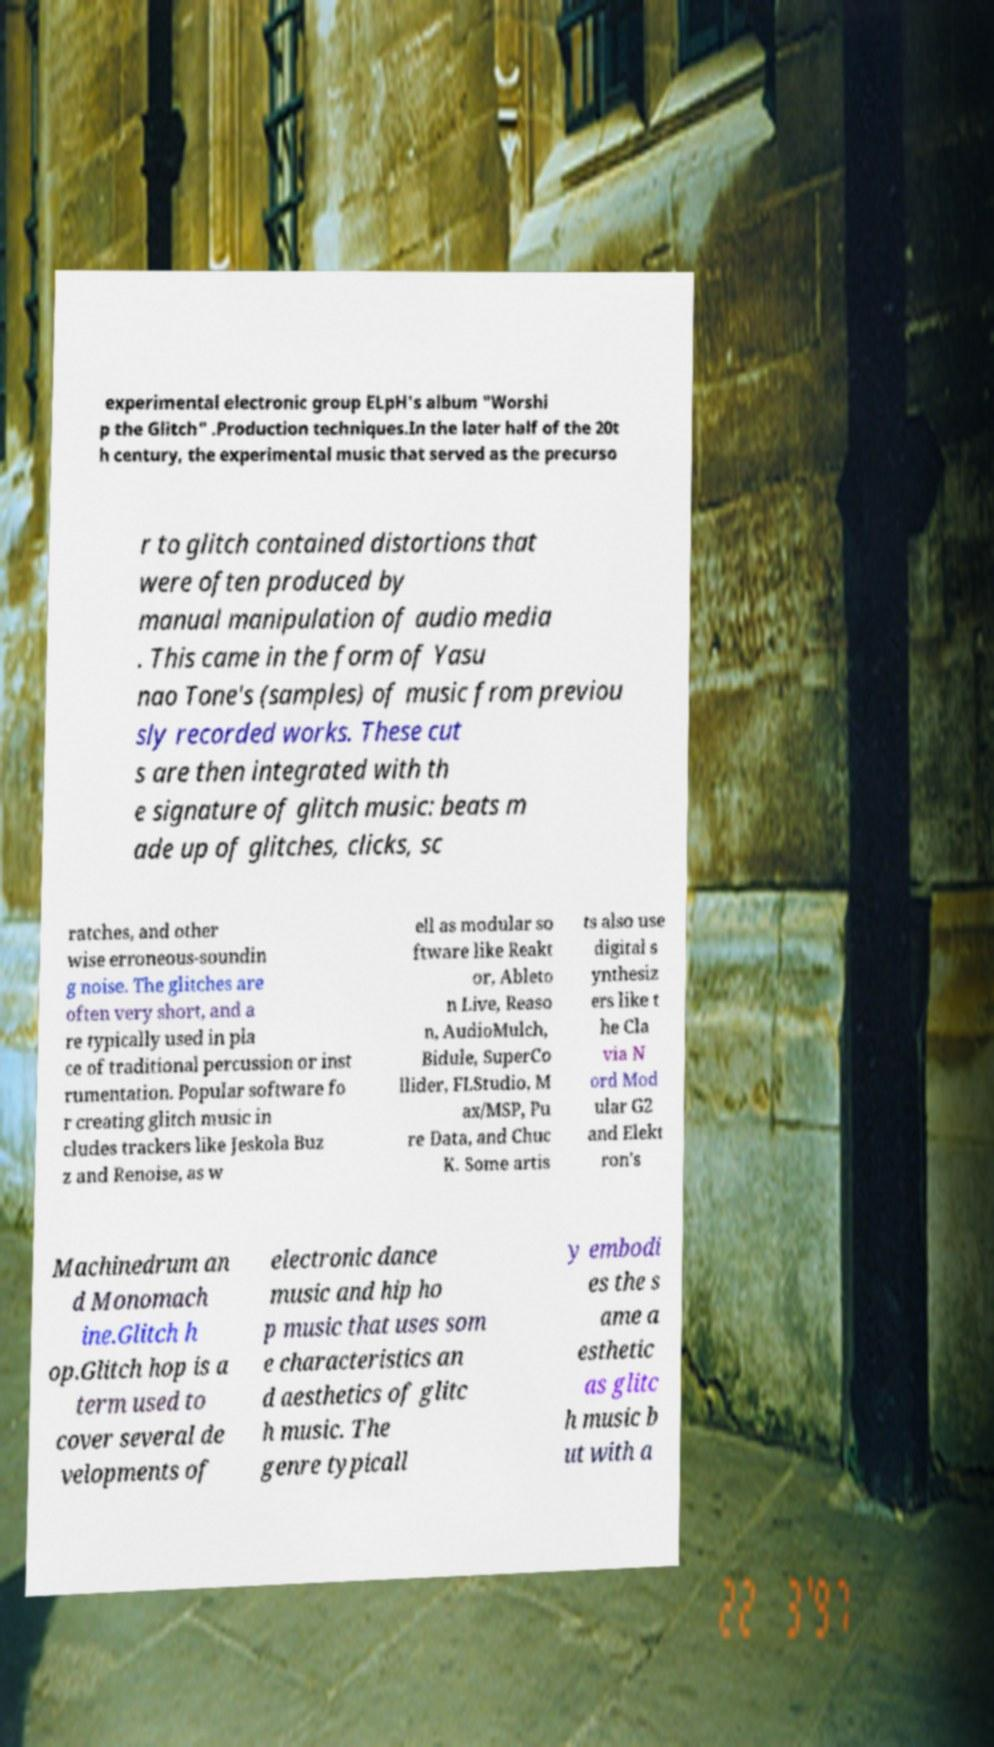Could you assist in decoding the text presented in this image and type it out clearly? experimental electronic group ELpH's album "Worshi p the Glitch" .Production techniques.In the later half of the 20t h century, the experimental music that served as the precurso r to glitch contained distortions that were often produced by manual manipulation of audio media . This came in the form of Yasu nao Tone's (samples) of music from previou sly recorded works. These cut s are then integrated with th e signature of glitch music: beats m ade up of glitches, clicks, sc ratches, and other wise erroneous-soundin g noise. The glitches are often very short, and a re typically used in pla ce of traditional percussion or inst rumentation. Popular software fo r creating glitch music in cludes trackers like Jeskola Buz z and Renoise, as w ell as modular so ftware like Reakt or, Ableto n Live, Reaso n, AudioMulch, Bidule, SuperCo llider, FLStudio, M ax/MSP, Pu re Data, and Chuc K. Some artis ts also use digital s ynthesiz ers like t he Cla via N ord Mod ular G2 and Elekt ron's Machinedrum an d Monomach ine.Glitch h op.Glitch hop is a term used to cover several de velopments of electronic dance music and hip ho p music that uses som e characteristics an d aesthetics of glitc h music. The genre typicall y embodi es the s ame a esthetic as glitc h music b ut with a 